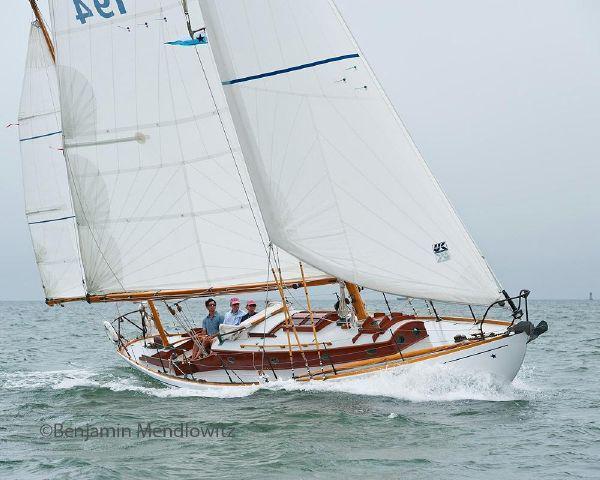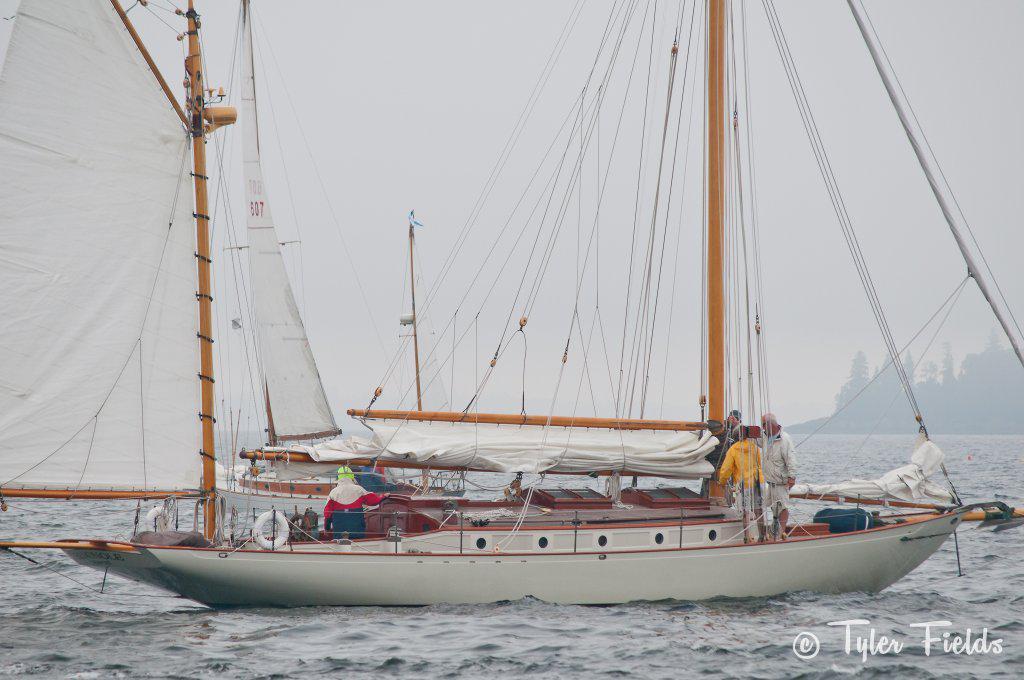The first image is the image on the left, the second image is the image on the right. For the images displayed, is the sentence "A striped flag is displayed at the front of a boat." factually correct? Answer yes or no. No. The first image is the image on the left, the second image is the image on the right. For the images shown, is this caption "There is an American flag visible on a sail boat." true? Answer yes or no. No. 